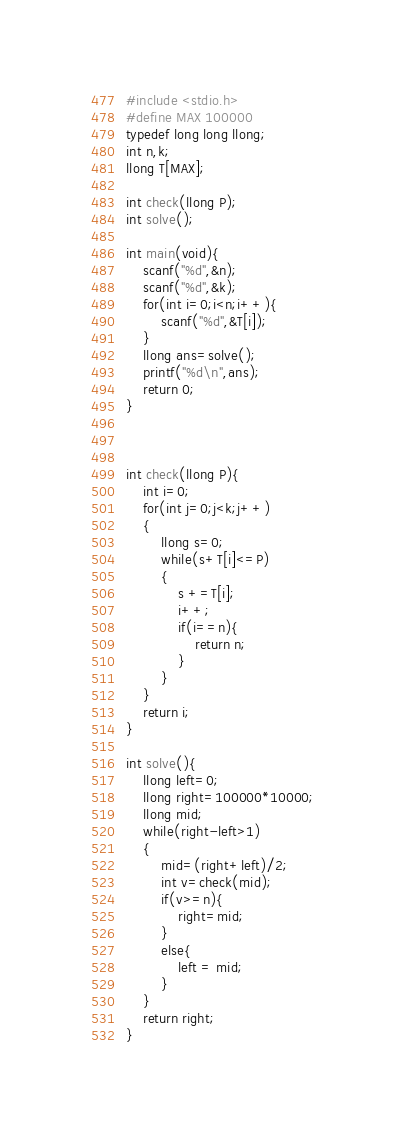<code> <loc_0><loc_0><loc_500><loc_500><_C_>#include <stdio.h>
#define MAX 100000
typedef long long llong;
int n,k;
llong T[MAX];

int check(llong P);
int solve();

int main(void){
	scanf("%d",&n);
	scanf("%d",&k);
	for(int i=0;i<n;i++){
		scanf("%d",&T[i]);
	}
	llong ans=solve();
	printf("%d\n",ans);
	return 0;
}



int check(llong P){
	int i=0;
	for(int j=0;j<k;j++)
	{
		llong s=0;
		while(s+T[i]<=P)
		{
			s +=T[i];
			i++;
			if(i==n){
				return n;
			}
		}
	}
	return i;
}

int solve(){
	llong left=0;
	llong right=100000*10000;
	llong mid;
	while(right-left>1)
	{
		mid=(right+left)/2;
		int v=check(mid);
		if(v>=n){
			right=mid;
		}
		else{
			left = mid;
		}
	}
	return right;
}



</code> 